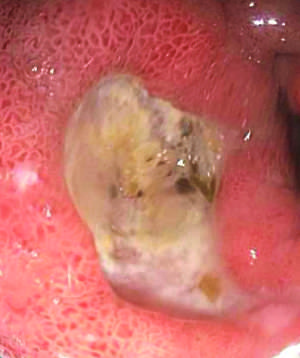what is endoscopic view of typical antral ulcer associated with?
Answer the question using a single word or phrase. Nsaid use 